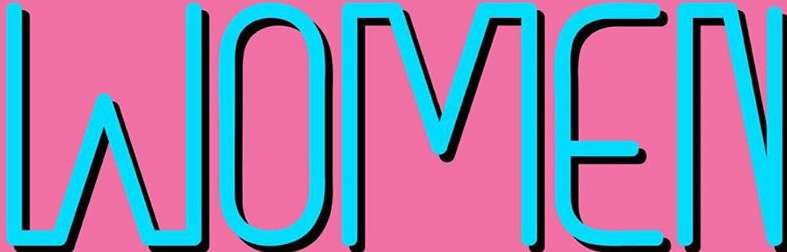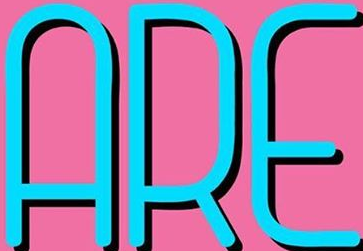What text appears in these images from left to right, separated by a semicolon? WOMEN; ARE 